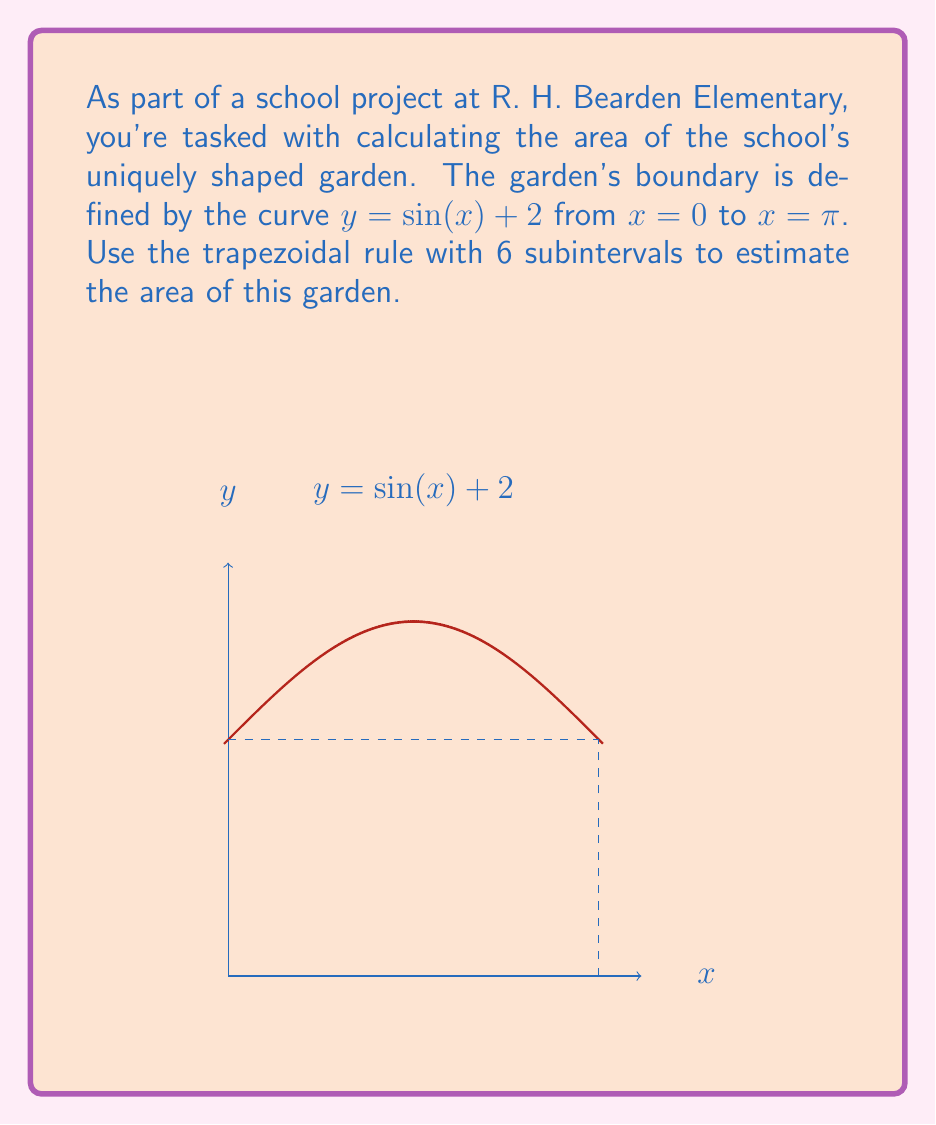Can you solve this math problem? To solve this problem using the trapezoidal rule with 6 subintervals, we'll follow these steps:

1) The trapezoidal rule formula is:

   $$\int_a^b f(x) dx \approx \frac{h}{2}[f(x_0) + 2f(x_1) + 2f(x_2) + ... + 2f(x_{n-1}) + f(x_n)]$$

   where $h = \frac{b-a}{n}$, $n$ is the number of subintervals, and $x_i = a + ih$.

2) In our case, $a = 0$, $b = \pi$, $n = 6$, and $f(x) = \sin(x) + 2$.

3) Calculate $h$:
   $h = \frac{\pi - 0}{6} = \frac{\pi}{6}$

4) Calculate $x_i$ values:
   $x_0 = 0$
   $x_1 = \frac{\pi}{6}$
   $x_2 = \frac{\pi}{3}$
   $x_3 = \frac{\pi}{2}$
   $x_4 = \frac{2\pi}{3}$
   $x_5 = \frac{5\pi}{6}$
   $x_6 = \pi$

5) Calculate $f(x_i)$ values:
   $f(x_0) = \sin(0) + 2 = 2$
   $f(x_1) = \sin(\frac{\pi}{6}) + 2 \approx 2.5$
   $f(x_2) = \sin(\frac{\pi}{3}) + 2 \approx 2.866$
   $f(x_3) = \sin(\frac{\pi}{2}) + 2 = 3$
   $f(x_4) = \sin(\frac{2\pi}{3}) + 2 \approx 2.866$
   $f(x_5) = \sin(\frac{5\pi}{6}) + 2 \approx 2.5$
   $f(x_6) = \sin(\pi) + 2 = 2$

6) Apply the trapezoidal rule:
   $$\text{Area} \approx \frac{\pi}{12}[2 + 2(2.5 + 2.866 + 3 + 2.866 + 2.5) + 2]$$
   $$\approx \frac{\pi}{12}[2 + 27.464 + 2]$$
   $$\approx \frac{\pi}{12}[31.464]$$
   $$\approx 8.232$$

Therefore, the estimated area of the garden is approximately 8.232 square units.
Answer: $8.232$ square units 